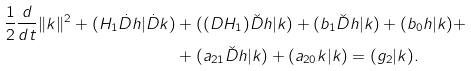Convert formula to latex. <formula><loc_0><loc_0><loc_500><loc_500>\frac { 1 } { 2 } \frac { d } { d t } \| k \| ^ { 2 } + ( H _ { 1 } \dot { D } h | \dot { D } k ) & + ( ( D H _ { 1 } ) \check { D } h | k ) + ( b _ { 1 } \check { D } h | k ) + ( b _ { 0 } h | k ) + \\ & + ( a _ { 2 1 } \check { D } h | k ) + ( a _ { 2 0 } k | k ) = ( g _ { 2 } | k ) .</formula> 